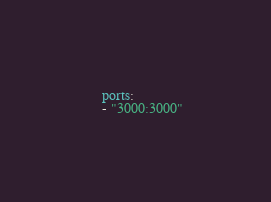Convert code to text. <code><loc_0><loc_0><loc_500><loc_500><_YAML_>    ports:
    - "3000:3000"
</code> 